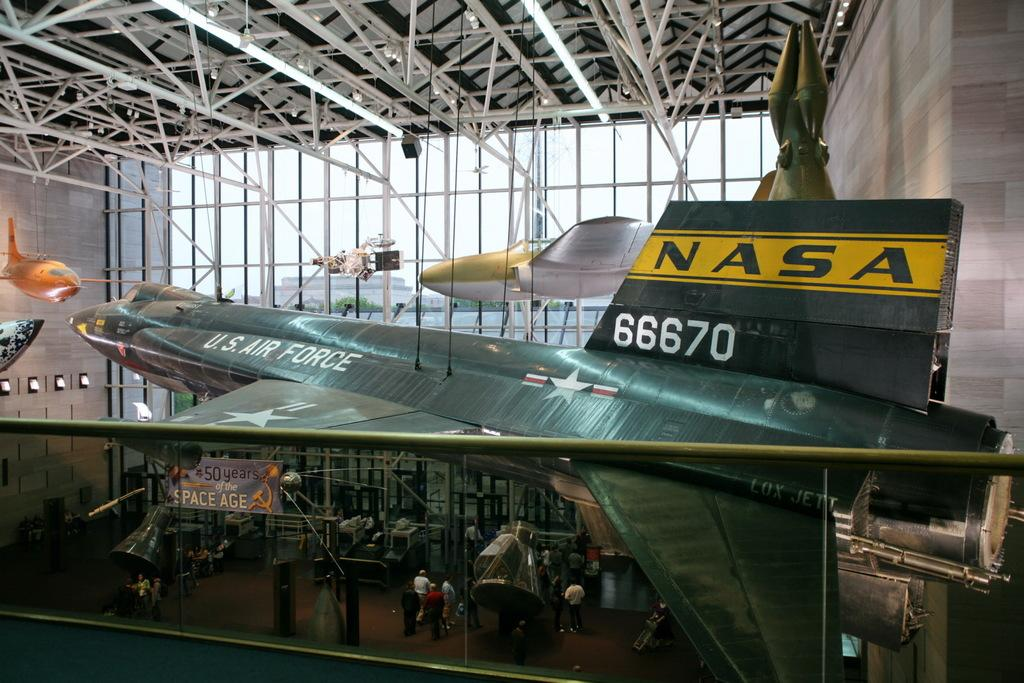What is the main subject of the image? The main subject of the image is a plane. Can you describe any other elements in the image? Yes, there are other people in the image. What type of flowers can be seen growing in the plane's territory in the image? There are no flowers or territory visible in the image; it features a plane and other people. What type of appliance is being used by the people in the image? There is no appliance visible in the image; it only features a plane and other people. 